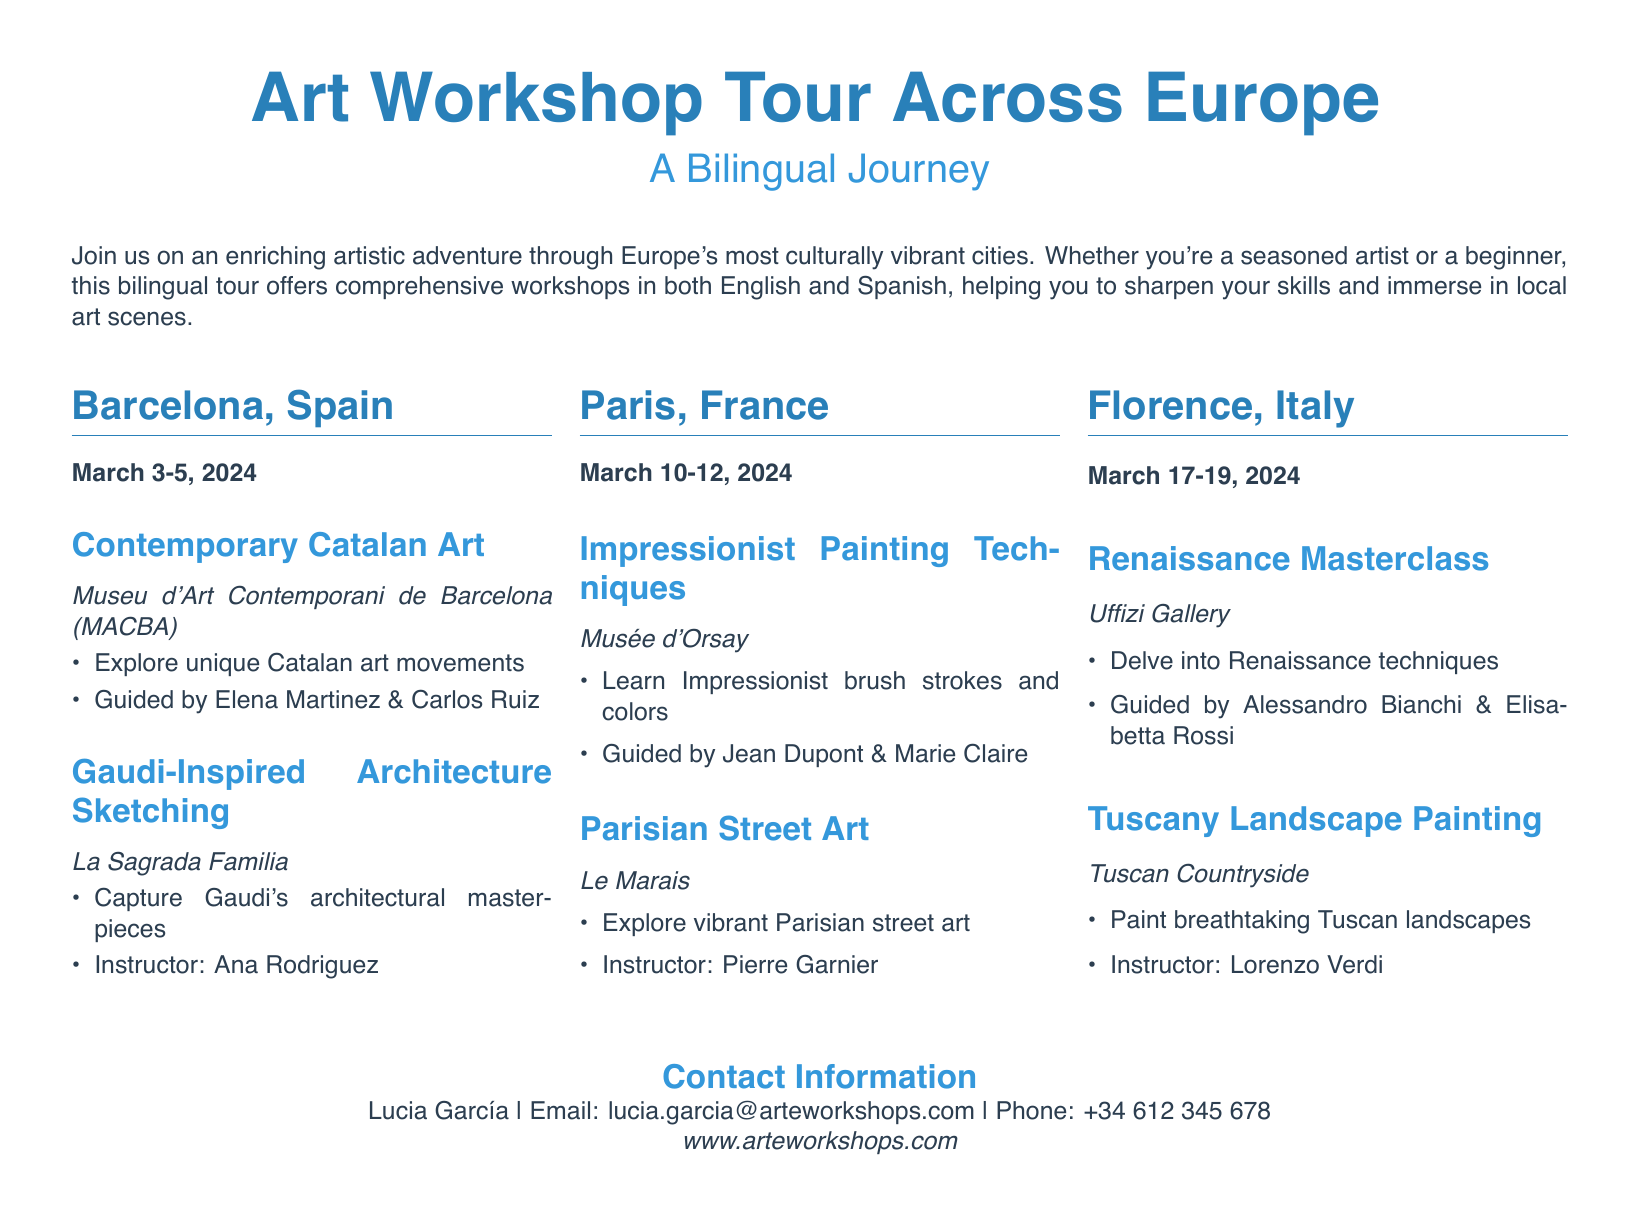What are the dates for the Barcelona workshop? The date listed for the Barcelona workshop is March 3-5, 2024.
Answer: March 3-5, 2024 Who is the instructor for the Gaudi-Inspired Architecture Sketching? The document states that Ana Rodriguez is the instructor for this session.
Answer: Ana Rodriguez Which city hosts a Renaissance Masterclass? The itinerary mentions that the Renaissance Masterclass takes place in Florence, Italy.
Answer: Florence, Italy What artistic technique is taught at the Musée d'Orsay? The document specifies that participants will learn Impressionist painting techniques at the Musée d'Orsay.
Answer: Impressionist painting techniques How many workshops are listed for each city? Each city features two workshops as outlined in the document.
Answer: Two workshops Who can participate in the bilingual tour? The document indicates that both seasoned artists and beginners are welcome to join the tour.
Answer: Seasoned artists and beginners What is the contact email for Lucia García? The contact email provided in the document is lucia.garcia@arteworkshops.com.
Answer: lucia.garcia@arteworkshops.com Which city is associated with capturing Tuscan landscapes? The document designates the Tuscan Countryside as the location for painting breathtaking landscapes, which is part of the Florence itinerary.
Answer: Tuscan Countryside What is the title of the itinerary? The itinerary is titled "Art Workshop Tour Across Europe."
Answer: Art Workshop Tour Across Europe 